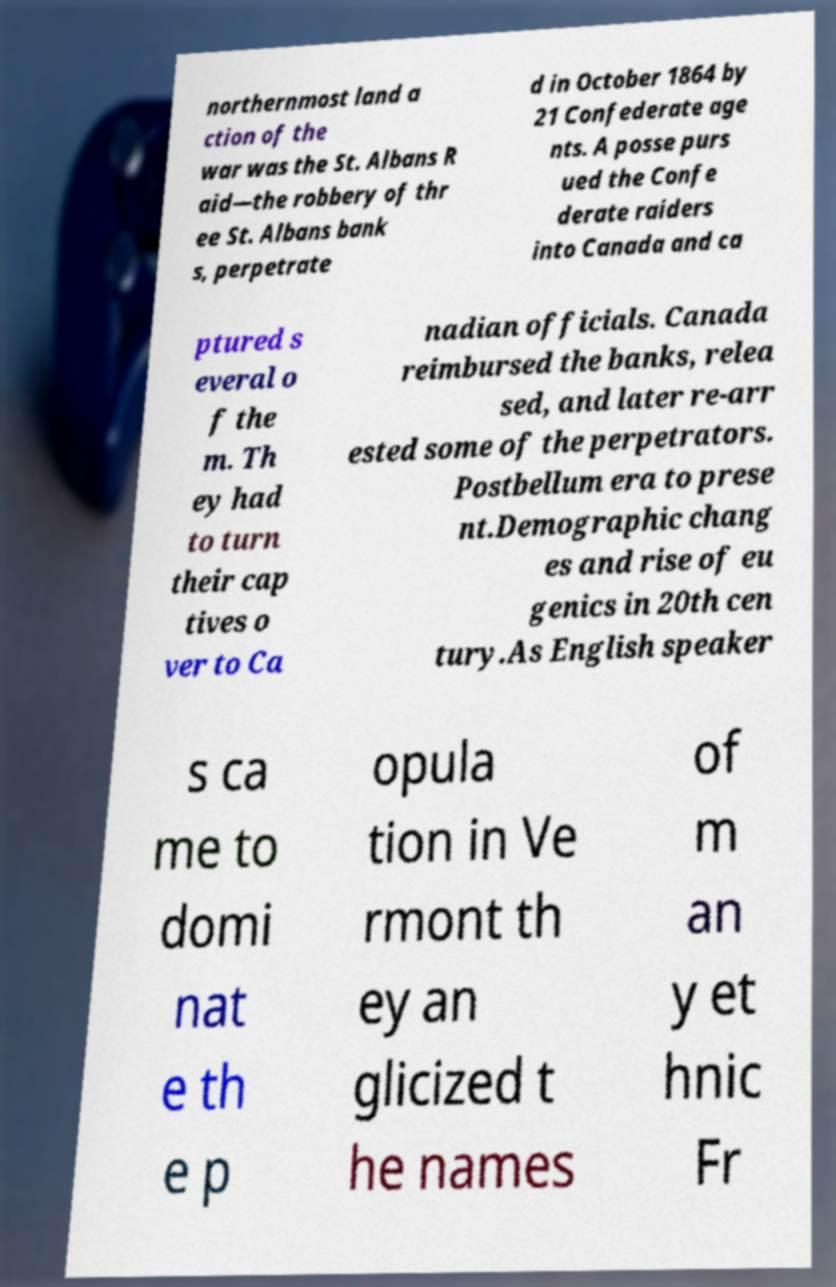What messages or text are displayed in this image? I need them in a readable, typed format. northernmost land a ction of the war was the St. Albans R aid—the robbery of thr ee St. Albans bank s, perpetrate d in October 1864 by 21 Confederate age nts. A posse purs ued the Confe derate raiders into Canada and ca ptured s everal o f the m. Th ey had to turn their cap tives o ver to Ca nadian officials. Canada reimbursed the banks, relea sed, and later re-arr ested some of the perpetrators. Postbellum era to prese nt.Demographic chang es and rise of eu genics in 20th cen tury.As English speaker s ca me to domi nat e th e p opula tion in Ve rmont th ey an glicized t he names of m an y et hnic Fr 